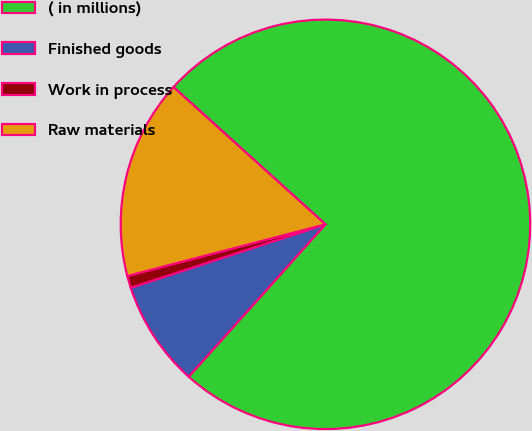Convert chart to OTSL. <chart><loc_0><loc_0><loc_500><loc_500><pie_chart><fcel>( in millions)<fcel>Finished goods<fcel>Work in process<fcel>Raw materials<nl><fcel>74.94%<fcel>8.35%<fcel>0.95%<fcel>15.75%<nl></chart> 